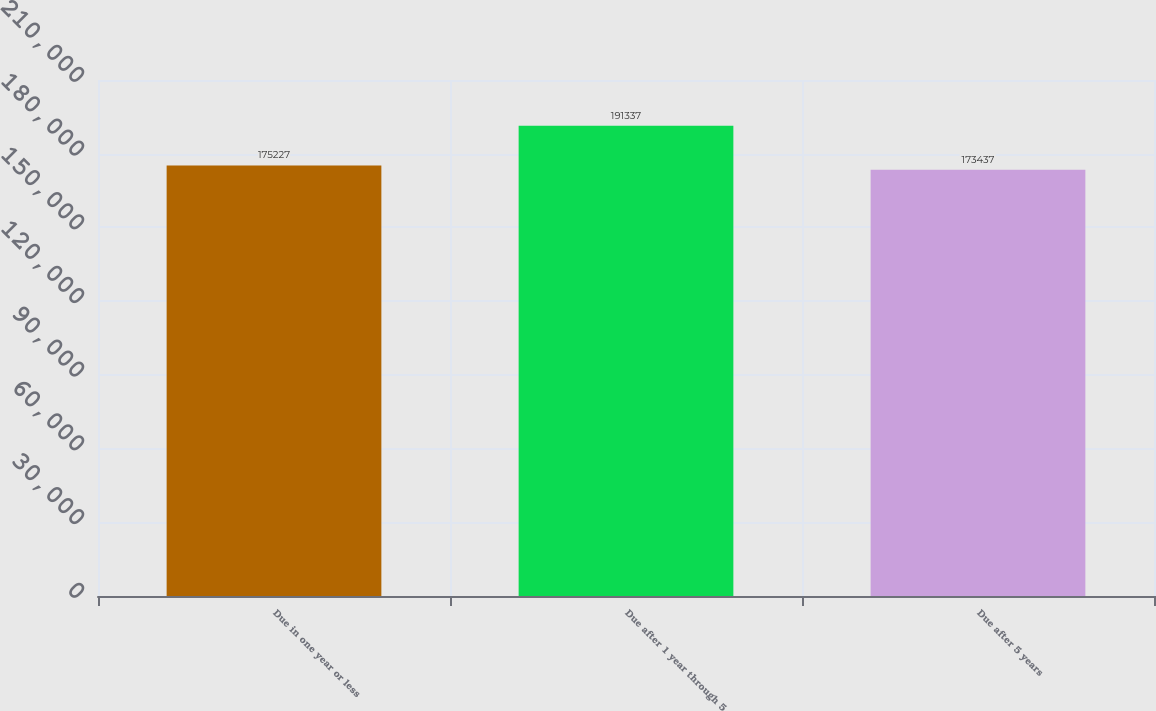Convert chart. <chart><loc_0><loc_0><loc_500><loc_500><bar_chart><fcel>Due in one year or less<fcel>Due after 1 year through 5<fcel>Due after 5 years<nl><fcel>175227<fcel>191337<fcel>173437<nl></chart> 